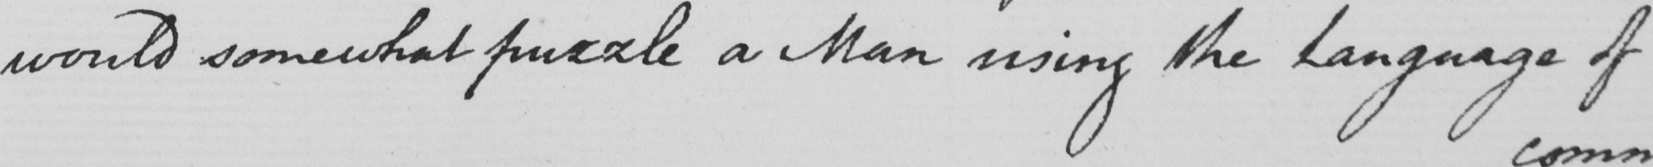What is written in this line of handwriting? would somewhat puzzle a Man using the Language of 